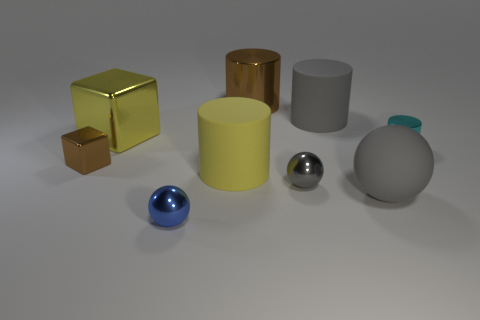Subtract all big gray rubber cylinders. How many cylinders are left? 3 Add 1 large brown things. How many objects exist? 10 Subtract 2 spheres. How many spheres are left? 1 Add 8 large gray cylinders. How many large gray cylinders are left? 9 Add 5 cylinders. How many cylinders exist? 9 Subtract all blue spheres. How many spheres are left? 2 Subtract 0 cyan blocks. How many objects are left? 9 Subtract all cylinders. How many objects are left? 5 Subtract all red cylinders. Subtract all purple spheres. How many cylinders are left? 4 Subtract all yellow balls. How many green cubes are left? 0 